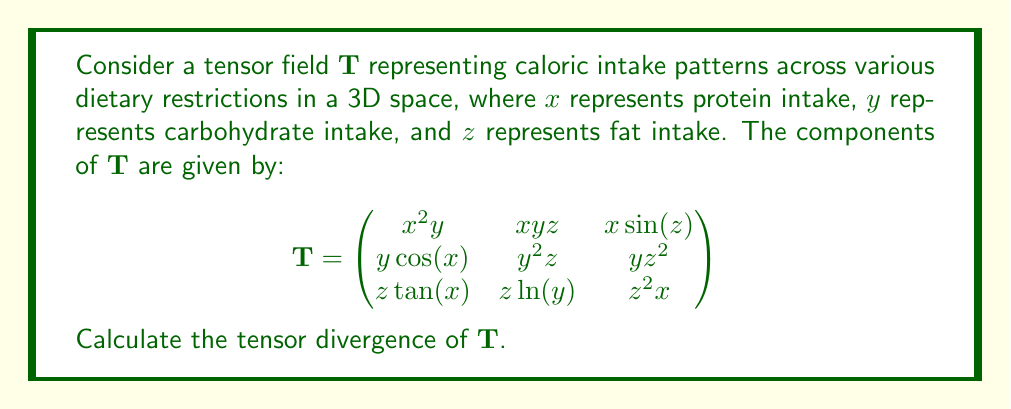Teach me how to tackle this problem. To calculate the tensor divergence of $\mathbf{T}$, we need to sum the partial derivatives of the diagonal elements with respect to their corresponding variables. The tensor divergence is given by:

$$\text{div}(\mathbf{T}) = \frac{\partial T_{11}}{\partial x} + \frac{\partial T_{22}}{\partial y} + \frac{\partial T_{33}}{\partial z}$$

Let's calculate each term:

1. $\frac{\partial T_{11}}{\partial x}$:
   $T_{11} = x^2y$
   $\frac{\partial T_{11}}{\partial x} = 2xy$

2. $\frac{\partial T_{22}}{\partial y}$:
   $T_{22} = y^2z$
   $\frac{\partial T_{22}}{\partial y} = 2yz$

3. $\frac{\partial T_{33}}{\partial z}$:
   $T_{33} = z^2x$
   $\frac{\partial T_{33}}{\partial z} = 2zx$

Now, we sum these partial derivatives:

$$\text{div}(\mathbf{T}) = 2xy + 2yz + 2zx$$

This expression represents the tensor divergence of the caloric intake patterns across various dietary restrictions.
Answer: $2xy + 2yz + 2zx$ 